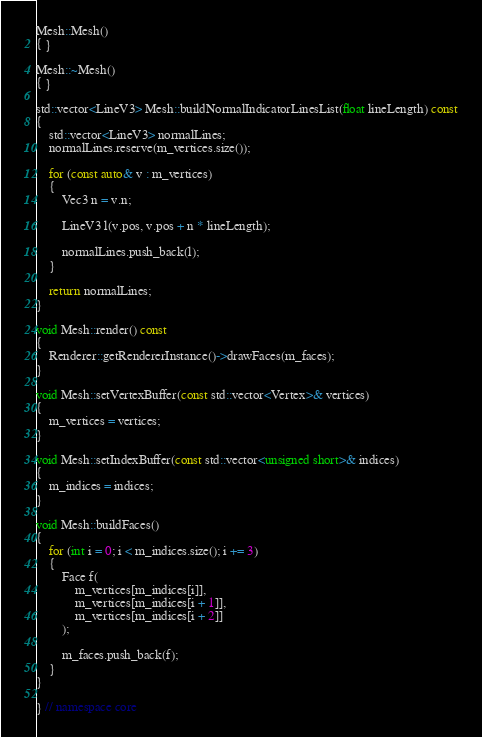<code> <loc_0><loc_0><loc_500><loc_500><_C++_>
Mesh::Mesh() 
{ }

Mesh::~Mesh() 
{ }

std::vector<LineV3> Mesh::buildNormalIndicatorLinesList(float lineLength) const
{
    std::vector<LineV3> normalLines;
    normalLines.reserve(m_vertices.size());

    for (const auto& v : m_vertices)
    {
        Vec3 n = v.n;

        LineV3 l(v.pos, v.pos + n * lineLength);

        normalLines.push_back(l);
    }

    return normalLines;
}

void Mesh::render() const
{
    Renderer::getRendererInstance()->drawFaces(m_faces);
}

void Mesh::setVertexBuffer(const std::vector<Vertex>& vertices)
{
    m_vertices = vertices;
}

void Mesh::setIndexBuffer(const std::vector<unsigned short>& indices)
{
    m_indices = indices;
}

void Mesh::buildFaces()
{
    for (int i = 0; i < m_indices.size(); i += 3)
    {
        Face f(
            m_vertices[m_indices[i]],
            m_vertices[m_indices[i + 1]],
            m_vertices[m_indices[i + 2]]
        );

        m_faces.push_back(f);
    }
}

} // namespace core
</code> 